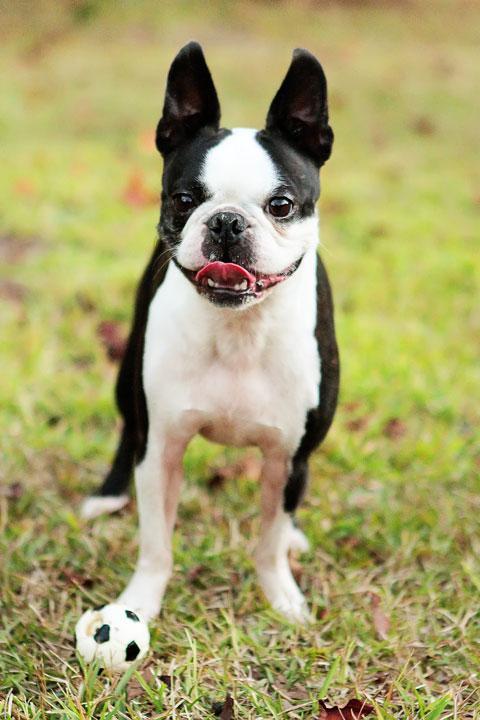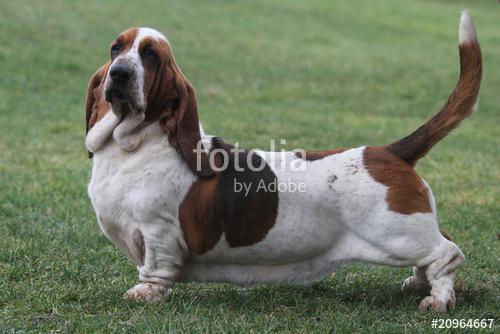The first image is the image on the left, the second image is the image on the right. For the images displayed, is the sentence "One dog is howling." factually correct? Answer yes or no. No. The first image is the image on the left, the second image is the image on the right. Given the left and right images, does the statement "The left image shows a howling basset hound with its head raised straight up, and the right image includes a basset hound with its ears flying in the wind." hold true? Answer yes or no. No. 